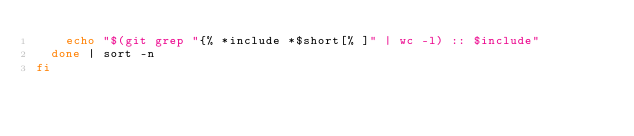Convert code to text. <code><loc_0><loc_0><loc_500><loc_500><_Bash_>    echo "$(git grep "{% *include *$short[% ]" | wc -l) :: $include"
  done | sort -n
fi
</code> 